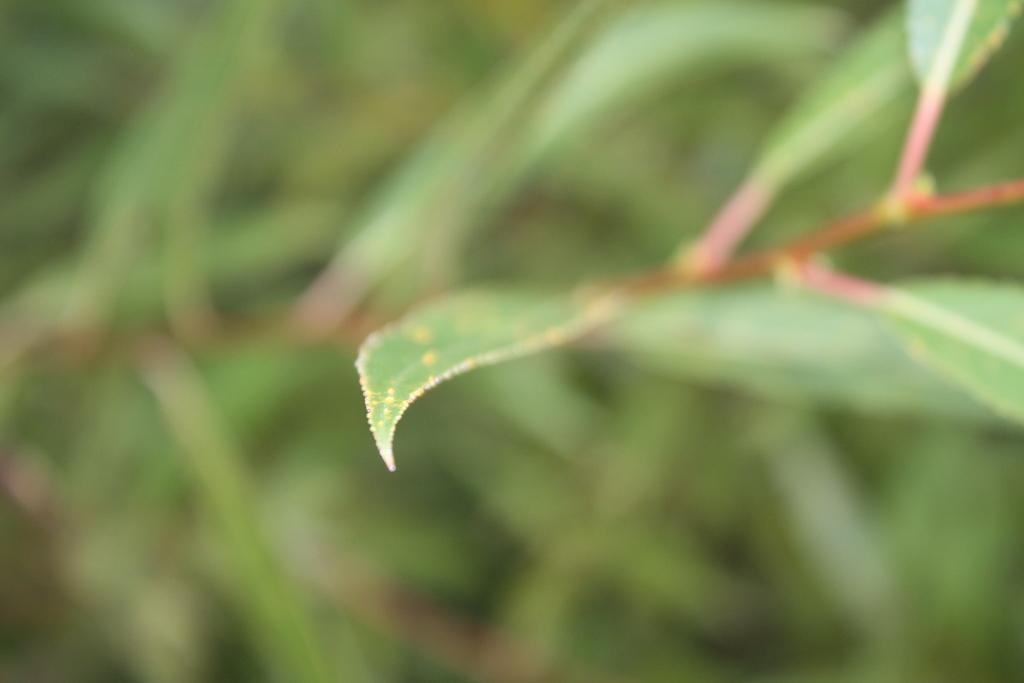How would you summarize this image in a sentence or two? In this picture we can see few leaves and blurry background. 